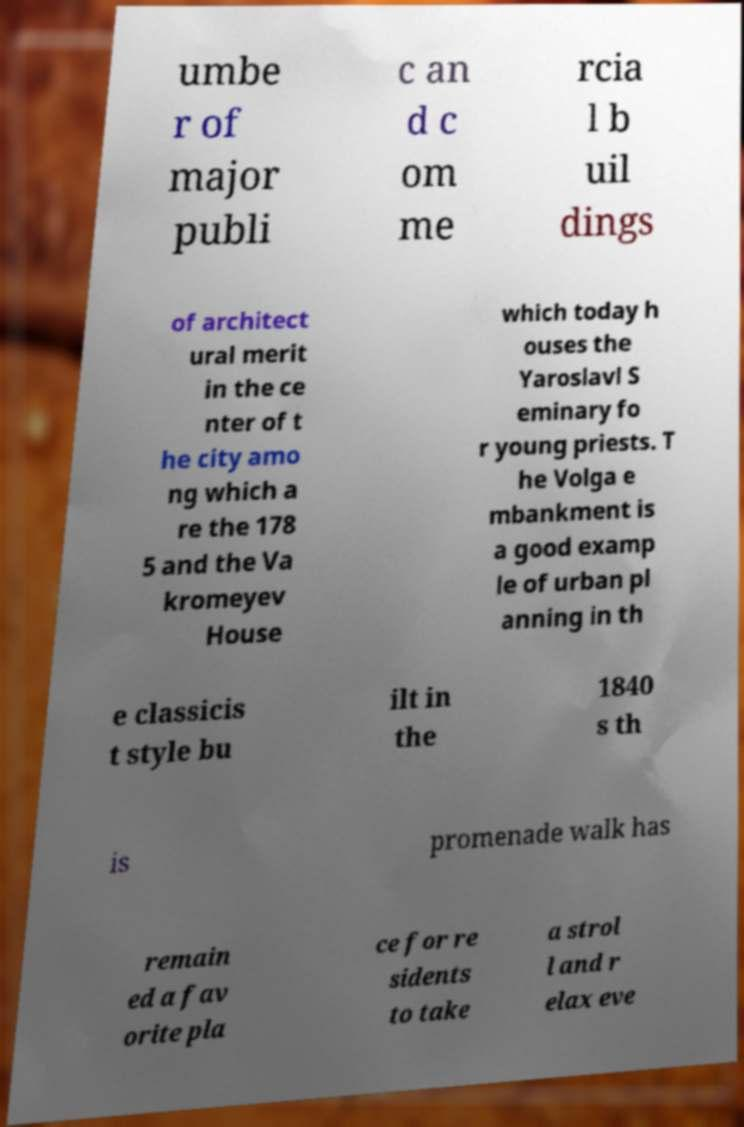For documentation purposes, I need the text within this image transcribed. Could you provide that? umbe r of major publi c an d c om me rcia l b uil dings of architect ural merit in the ce nter of t he city amo ng which a re the 178 5 and the Va kromeyev House which today h ouses the Yaroslavl S eminary fo r young priests. T he Volga e mbankment is a good examp le of urban pl anning in th e classicis t style bu ilt in the 1840 s th is promenade walk has remain ed a fav orite pla ce for re sidents to take a strol l and r elax eve 